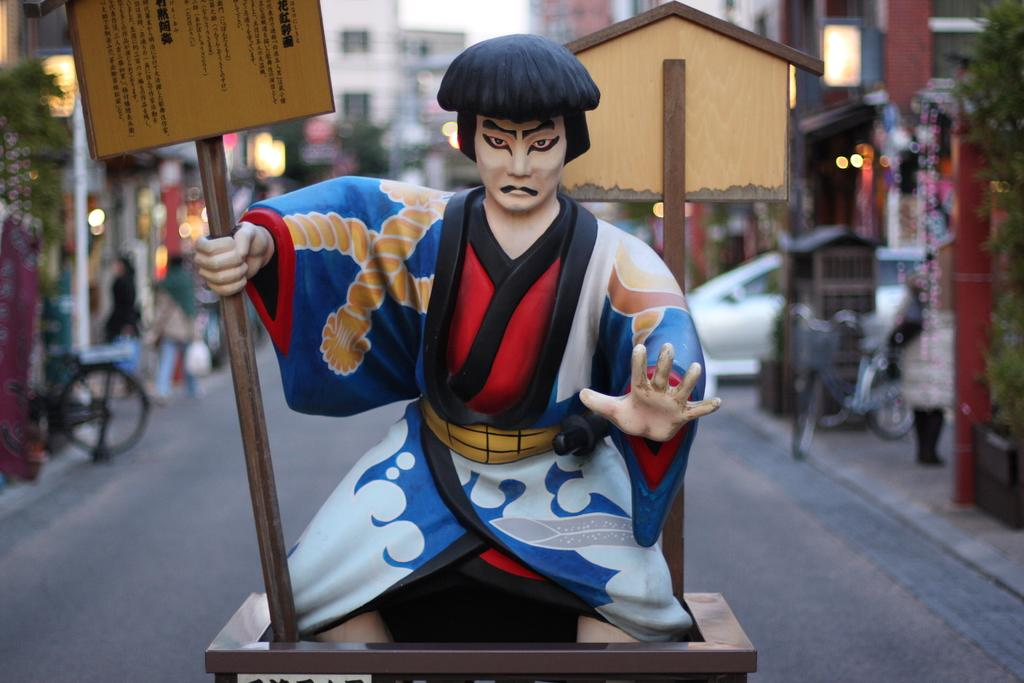What is the statue holding in the image? The statue is holding a board with a pole. Can you describe the background of the image? The background is blurred, but there are buildings, people, lights, plants, and vehicles visible. What is the main object in the foreground of the image? The main object in the foreground is the statue holding a board with a pole. What is the price of the hospital in the image? There is no hospital present in the image, so it is not possible to determine its price. 